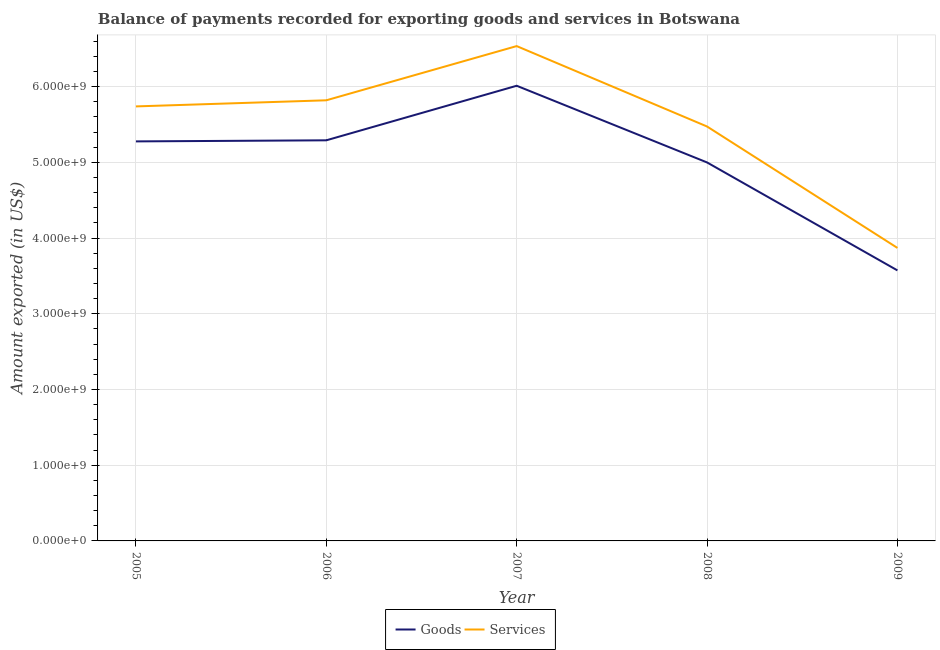How many different coloured lines are there?
Your response must be concise. 2. Does the line corresponding to amount of services exported intersect with the line corresponding to amount of goods exported?
Provide a succinct answer. No. Is the number of lines equal to the number of legend labels?
Offer a very short reply. Yes. What is the amount of goods exported in 2009?
Offer a terse response. 3.57e+09. Across all years, what is the maximum amount of services exported?
Provide a short and direct response. 6.54e+09. Across all years, what is the minimum amount of goods exported?
Make the answer very short. 3.57e+09. What is the total amount of services exported in the graph?
Keep it short and to the point. 2.74e+1. What is the difference between the amount of goods exported in 2005 and that in 2006?
Provide a short and direct response. -1.42e+07. What is the difference between the amount of services exported in 2008 and the amount of goods exported in 2005?
Give a very brief answer. 1.97e+08. What is the average amount of services exported per year?
Give a very brief answer. 5.49e+09. In the year 2008, what is the difference between the amount of services exported and amount of goods exported?
Ensure brevity in your answer.  4.75e+08. What is the ratio of the amount of services exported in 2006 to that in 2008?
Your response must be concise. 1.06. What is the difference between the highest and the second highest amount of goods exported?
Your answer should be very brief. 7.20e+08. What is the difference between the highest and the lowest amount of services exported?
Give a very brief answer. 2.67e+09. In how many years, is the amount of goods exported greater than the average amount of goods exported taken over all years?
Provide a succinct answer. 3. Is the sum of the amount of goods exported in 2005 and 2009 greater than the maximum amount of services exported across all years?
Make the answer very short. Yes. Does the amount of services exported monotonically increase over the years?
Ensure brevity in your answer.  No. Is the amount of services exported strictly greater than the amount of goods exported over the years?
Keep it short and to the point. Yes. How many lines are there?
Make the answer very short. 2. How many years are there in the graph?
Provide a succinct answer. 5. Does the graph contain any zero values?
Provide a succinct answer. No. Does the graph contain grids?
Your response must be concise. Yes. What is the title of the graph?
Your answer should be very brief. Balance of payments recorded for exporting goods and services in Botswana. What is the label or title of the X-axis?
Make the answer very short. Year. What is the label or title of the Y-axis?
Your response must be concise. Amount exported (in US$). What is the Amount exported (in US$) in Goods in 2005?
Give a very brief answer. 5.28e+09. What is the Amount exported (in US$) of Services in 2005?
Your response must be concise. 5.74e+09. What is the Amount exported (in US$) in Goods in 2006?
Keep it short and to the point. 5.29e+09. What is the Amount exported (in US$) of Services in 2006?
Offer a terse response. 5.82e+09. What is the Amount exported (in US$) of Goods in 2007?
Offer a very short reply. 6.01e+09. What is the Amount exported (in US$) of Services in 2007?
Your answer should be very brief. 6.54e+09. What is the Amount exported (in US$) in Goods in 2008?
Ensure brevity in your answer.  5.00e+09. What is the Amount exported (in US$) of Services in 2008?
Offer a terse response. 5.47e+09. What is the Amount exported (in US$) in Goods in 2009?
Make the answer very short. 3.57e+09. What is the Amount exported (in US$) of Services in 2009?
Your answer should be compact. 3.87e+09. Across all years, what is the maximum Amount exported (in US$) of Goods?
Your answer should be compact. 6.01e+09. Across all years, what is the maximum Amount exported (in US$) of Services?
Give a very brief answer. 6.54e+09. Across all years, what is the minimum Amount exported (in US$) of Goods?
Provide a short and direct response. 3.57e+09. Across all years, what is the minimum Amount exported (in US$) of Services?
Your answer should be very brief. 3.87e+09. What is the total Amount exported (in US$) in Goods in the graph?
Make the answer very short. 2.52e+1. What is the total Amount exported (in US$) in Services in the graph?
Your answer should be very brief. 2.74e+1. What is the difference between the Amount exported (in US$) in Goods in 2005 and that in 2006?
Provide a succinct answer. -1.42e+07. What is the difference between the Amount exported (in US$) of Services in 2005 and that in 2006?
Give a very brief answer. -8.08e+07. What is the difference between the Amount exported (in US$) in Goods in 2005 and that in 2007?
Provide a short and direct response. -7.35e+08. What is the difference between the Amount exported (in US$) of Services in 2005 and that in 2007?
Your answer should be very brief. -7.97e+08. What is the difference between the Amount exported (in US$) of Goods in 2005 and that in 2008?
Make the answer very short. 2.78e+08. What is the difference between the Amount exported (in US$) of Services in 2005 and that in 2008?
Make the answer very short. 2.65e+08. What is the difference between the Amount exported (in US$) of Goods in 2005 and that in 2009?
Offer a terse response. 1.70e+09. What is the difference between the Amount exported (in US$) in Services in 2005 and that in 2009?
Your answer should be very brief. 1.87e+09. What is the difference between the Amount exported (in US$) in Goods in 2006 and that in 2007?
Your answer should be very brief. -7.20e+08. What is the difference between the Amount exported (in US$) of Services in 2006 and that in 2007?
Your response must be concise. -7.16e+08. What is the difference between the Amount exported (in US$) in Goods in 2006 and that in 2008?
Offer a very short reply. 2.92e+08. What is the difference between the Amount exported (in US$) in Services in 2006 and that in 2008?
Provide a short and direct response. 3.46e+08. What is the difference between the Amount exported (in US$) of Goods in 2006 and that in 2009?
Make the answer very short. 1.72e+09. What is the difference between the Amount exported (in US$) of Services in 2006 and that in 2009?
Your answer should be compact. 1.95e+09. What is the difference between the Amount exported (in US$) in Goods in 2007 and that in 2008?
Offer a very short reply. 1.01e+09. What is the difference between the Amount exported (in US$) in Services in 2007 and that in 2008?
Your answer should be compact. 1.06e+09. What is the difference between the Amount exported (in US$) of Goods in 2007 and that in 2009?
Keep it short and to the point. 2.44e+09. What is the difference between the Amount exported (in US$) of Services in 2007 and that in 2009?
Provide a succinct answer. 2.67e+09. What is the difference between the Amount exported (in US$) in Goods in 2008 and that in 2009?
Ensure brevity in your answer.  1.43e+09. What is the difference between the Amount exported (in US$) in Services in 2008 and that in 2009?
Offer a terse response. 1.60e+09. What is the difference between the Amount exported (in US$) in Goods in 2005 and the Amount exported (in US$) in Services in 2006?
Provide a short and direct response. -5.43e+08. What is the difference between the Amount exported (in US$) of Goods in 2005 and the Amount exported (in US$) of Services in 2007?
Keep it short and to the point. -1.26e+09. What is the difference between the Amount exported (in US$) of Goods in 2005 and the Amount exported (in US$) of Services in 2008?
Ensure brevity in your answer.  -1.97e+08. What is the difference between the Amount exported (in US$) of Goods in 2005 and the Amount exported (in US$) of Services in 2009?
Your answer should be very brief. 1.41e+09. What is the difference between the Amount exported (in US$) in Goods in 2006 and the Amount exported (in US$) in Services in 2007?
Make the answer very short. -1.24e+09. What is the difference between the Amount exported (in US$) of Goods in 2006 and the Amount exported (in US$) of Services in 2008?
Provide a succinct answer. -1.82e+08. What is the difference between the Amount exported (in US$) in Goods in 2006 and the Amount exported (in US$) in Services in 2009?
Your answer should be compact. 1.42e+09. What is the difference between the Amount exported (in US$) of Goods in 2007 and the Amount exported (in US$) of Services in 2008?
Offer a terse response. 5.38e+08. What is the difference between the Amount exported (in US$) of Goods in 2007 and the Amount exported (in US$) of Services in 2009?
Ensure brevity in your answer.  2.14e+09. What is the difference between the Amount exported (in US$) of Goods in 2008 and the Amount exported (in US$) of Services in 2009?
Ensure brevity in your answer.  1.13e+09. What is the average Amount exported (in US$) in Goods per year?
Ensure brevity in your answer.  5.03e+09. What is the average Amount exported (in US$) in Services per year?
Provide a succinct answer. 5.49e+09. In the year 2005, what is the difference between the Amount exported (in US$) in Goods and Amount exported (in US$) in Services?
Provide a short and direct response. -4.62e+08. In the year 2006, what is the difference between the Amount exported (in US$) in Goods and Amount exported (in US$) in Services?
Offer a very short reply. -5.29e+08. In the year 2007, what is the difference between the Amount exported (in US$) of Goods and Amount exported (in US$) of Services?
Offer a very short reply. -5.24e+08. In the year 2008, what is the difference between the Amount exported (in US$) of Goods and Amount exported (in US$) of Services?
Keep it short and to the point. -4.75e+08. In the year 2009, what is the difference between the Amount exported (in US$) of Goods and Amount exported (in US$) of Services?
Give a very brief answer. -2.97e+08. What is the ratio of the Amount exported (in US$) in Goods in 2005 to that in 2006?
Give a very brief answer. 1. What is the ratio of the Amount exported (in US$) of Services in 2005 to that in 2006?
Make the answer very short. 0.99. What is the ratio of the Amount exported (in US$) in Goods in 2005 to that in 2007?
Give a very brief answer. 0.88. What is the ratio of the Amount exported (in US$) of Services in 2005 to that in 2007?
Offer a terse response. 0.88. What is the ratio of the Amount exported (in US$) of Goods in 2005 to that in 2008?
Ensure brevity in your answer.  1.06. What is the ratio of the Amount exported (in US$) in Services in 2005 to that in 2008?
Offer a very short reply. 1.05. What is the ratio of the Amount exported (in US$) in Goods in 2005 to that in 2009?
Your response must be concise. 1.48. What is the ratio of the Amount exported (in US$) of Services in 2005 to that in 2009?
Your response must be concise. 1.48. What is the ratio of the Amount exported (in US$) in Goods in 2006 to that in 2007?
Your response must be concise. 0.88. What is the ratio of the Amount exported (in US$) of Services in 2006 to that in 2007?
Offer a terse response. 0.89. What is the ratio of the Amount exported (in US$) in Goods in 2006 to that in 2008?
Give a very brief answer. 1.06. What is the ratio of the Amount exported (in US$) in Services in 2006 to that in 2008?
Give a very brief answer. 1.06. What is the ratio of the Amount exported (in US$) of Goods in 2006 to that in 2009?
Make the answer very short. 1.48. What is the ratio of the Amount exported (in US$) in Services in 2006 to that in 2009?
Your answer should be very brief. 1.5. What is the ratio of the Amount exported (in US$) of Goods in 2007 to that in 2008?
Keep it short and to the point. 1.2. What is the ratio of the Amount exported (in US$) in Services in 2007 to that in 2008?
Give a very brief answer. 1.19. What is the ratio of the Amount exported (in US$) of Goods in 2007 to that in 2009?
Keep it short and to the point. 1.68. What is the ratio of the Amount exported (in US$) in Services in 2007 to that in 2009?
Provide a succinct answer. 1.69. What is the ratio of the Amount exported (in US$) in Goods in 2008 to that in 2009?
Provide a succinct answer. 1.4. What is the ratio of the Amount exported (in US$) in Services in 2008 to that in 2009?
Ensure brevity in your answer.  1.41. What is the difference between the highest and the second highest Amount exported (in US$) of Goods?
Keep it short and to the point. 7.20e+08. What is the difference between the highest and the second highest Amount exported (in US$) of Services?
Your response must be concise. 7.16e+08. What is the difference between the highest and the lowest Amount exported (in US$) of Goods?
Your answer should be compact. 2.44e+09. What is the difference between the highest and the lowest Amount exported (in US$) in Services?
Keep it short and to the point. 2.67e+09. 